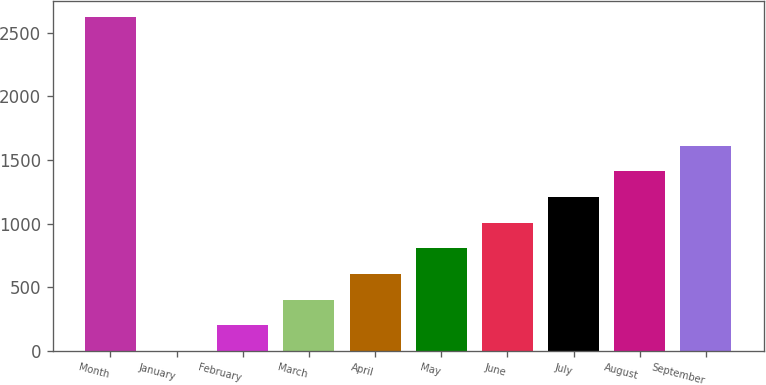<chart> <loc_0><loc_0><loc_500><loc_500><bar_chart><fcel>Month<fcel>January<fcel>February<fcel>March<fcel>April<fcel>May<fcel>June<fcel>July<fcel>August<fcel>September<nl><fcel>2619.42<fcel>0.18<fcel>201.66<fcel>403.14<fcel>604.62<fcel>806.1<fcel>1007.58<fcel>1209.06<fcel>1410.54<fcel>1612.02<nl></chart> 